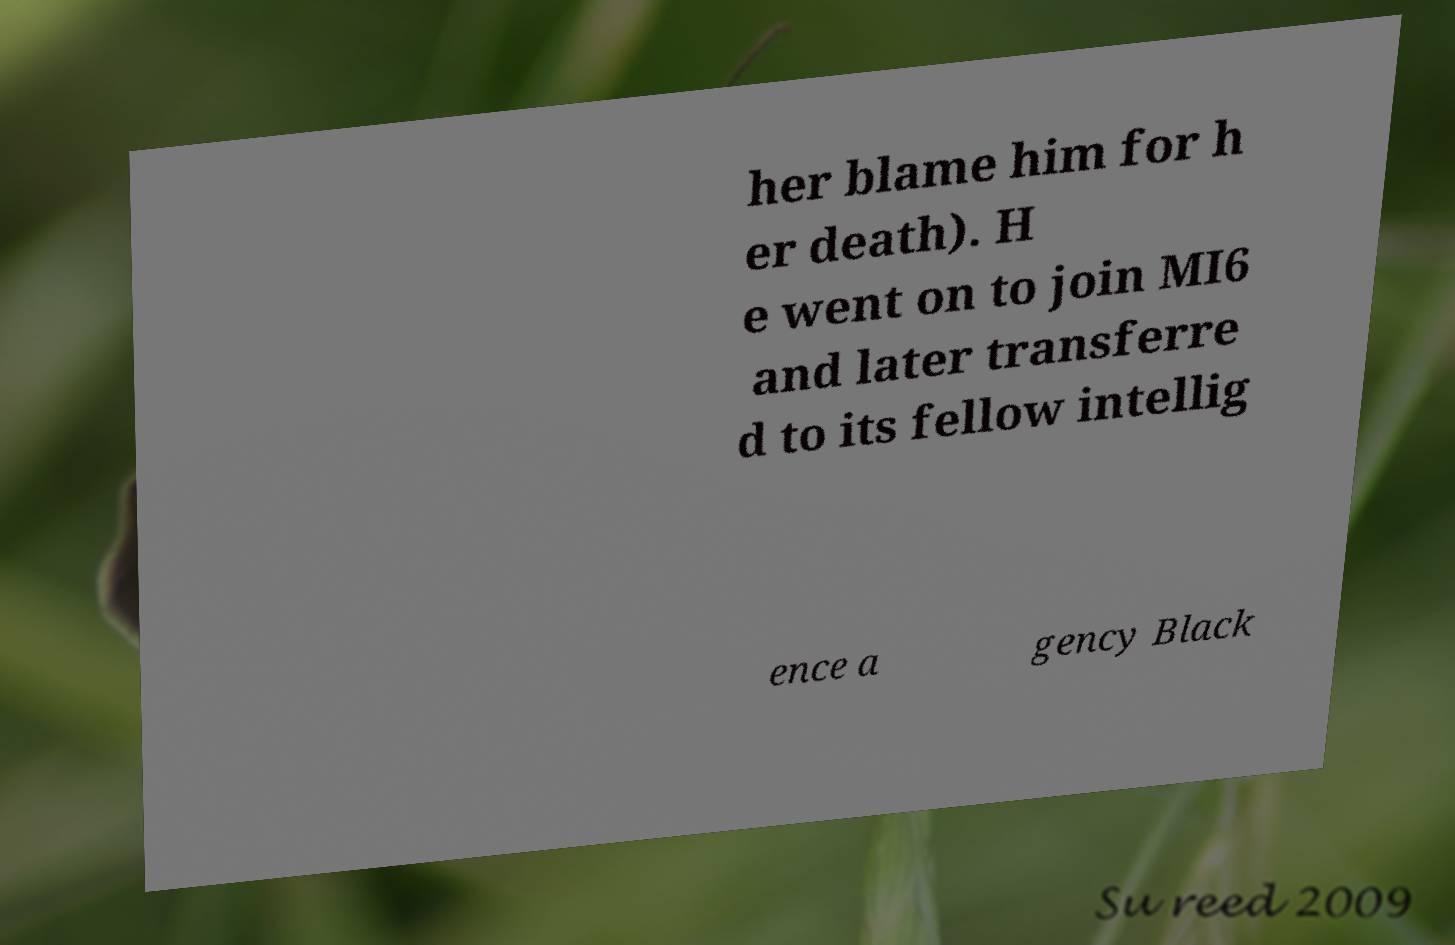Could you assist in decoding the text presented in this image and type it out clearly? her blame him for h er death). H e went on to join MI6 and later transferre d to its fellow intellig ence a gency Black 